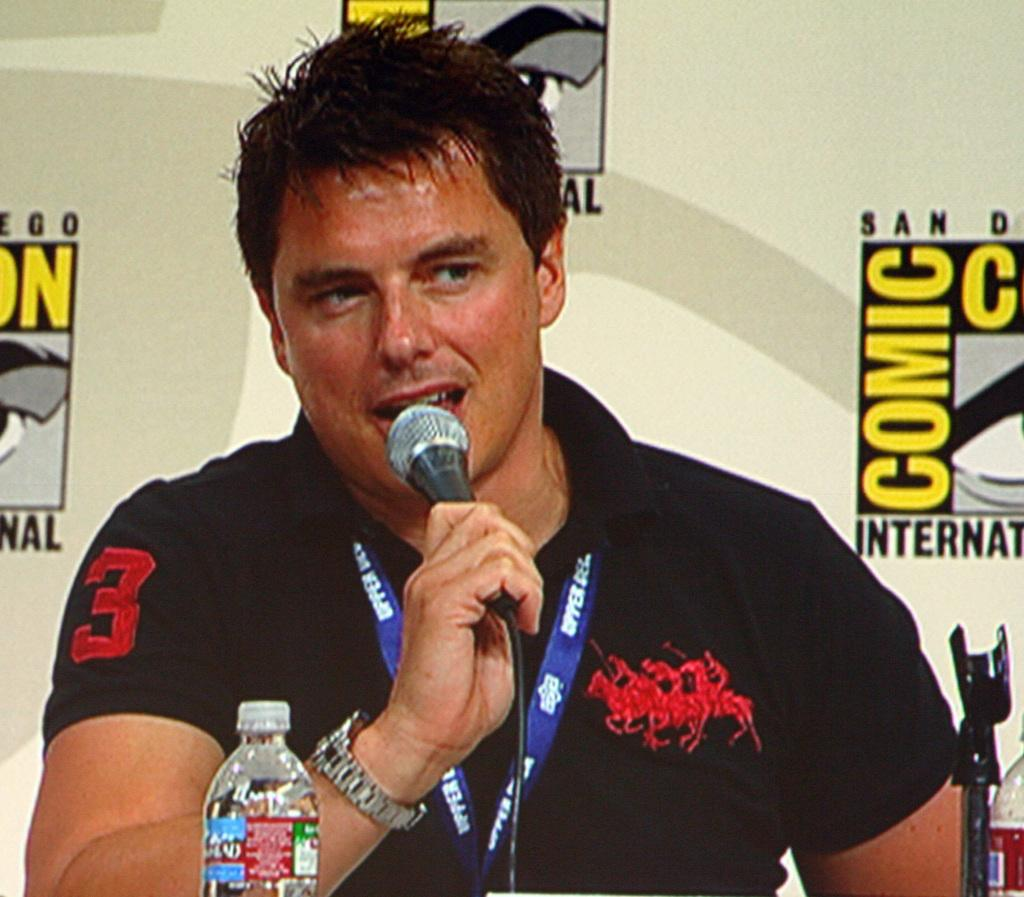Who is the main subject in the image? There is a man in the image. What is the man doing in the image? The man is speaking on a microphone. Can you identify any other objects in the image? Yes, there is a water bottle visible in the image. What can be seen in the background of the image? There is a hoarding in the background of the image. What type of ring can be seen on the man's finger in the image? There is no ring visible on the man's finger in the image. Has the man received a letter recently, as seen in the image? There is no letter present in the image, so it cannot be determined if the man has received one. 